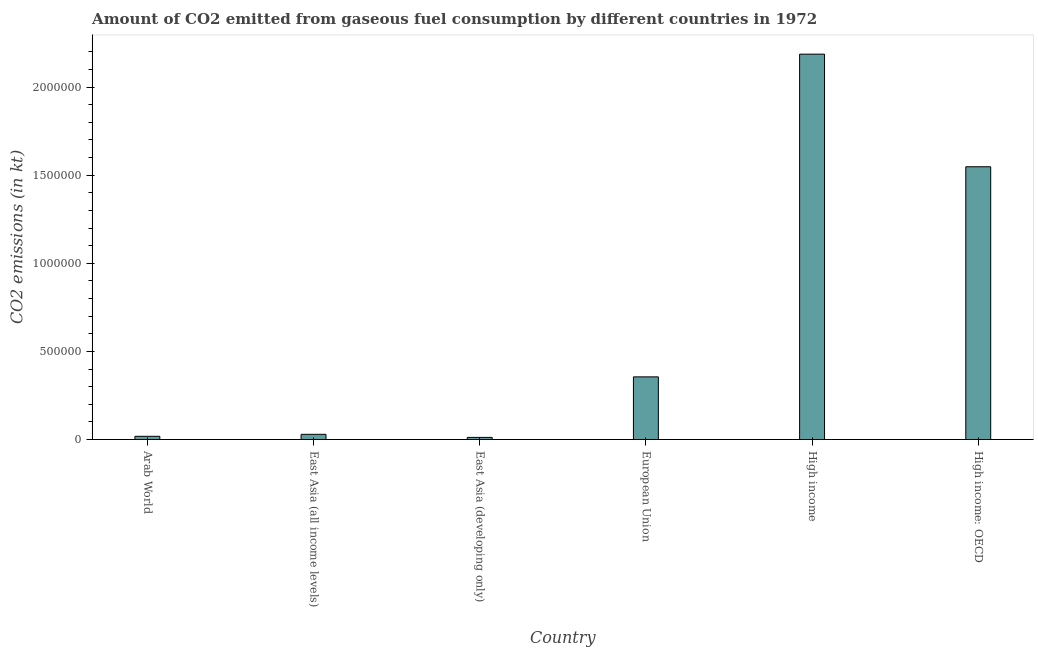Does the graph contain grids?
Your answer should be compact. No. What is the title of the graph?
Offer a terse response. Amount of CO2 emitted from gaseous fuel consumption by different countries in 1972. What is the label or title of the X-axis?
Your answer should be compact. Country. What is the label or title of the Y-axis?
Provide a short and direct response. CO2 emissions (in kt). What is the co2 emissions from gaseous fuel consumption in Arab World?
Provide a succinct answer. 1.83e+04. Across all countries, what is the maximum co2 emissions from gaseous fuel consumption?
Make the answer very short. 2.19e+06. Across all countries, what is the minimum co2 emissions from gaseous fuel consumption?
Keep it short and to the point. 1.21e+04. In which country was the co2 emissions from gaseous fuel consumption minimum?
Provide a short and direct response. East Asia (developing only). What is the sum of the co2 emissions from gaseous fuel consumption?
Give a very brief answer. 4.15e+06. What is the difference between the co2 emissions from gaseous fuel consumption in Arab World and High income: OECD?
Ensure brevity in your answer.  -1.53e+06. What is the average co2 emissions from gaseous fuel consumption per country?
Provide a succinct answer. 6.92e+05. What is the median co2 emissions from gaseous fuel consumption?
Your answer should be compact. 1.93e+05. In how many countries, is the co2 emissions from gaseous fuel consumption greater than 1900000 kt?
Offer a very short reply. 1. What is the ratio of the co2 emissions from gaseous fuel consumption in East Asia (all income levels) to that in High income?
Provide a succinct answer. 0.01. Is the co2 emissions from gaseous fuel consumption in Arab World less than that in High income?
Your answer should be very brief. Yes. Is the difference between the co2 emissions from gaseous fuel consumption in East Asia (all income levels) and European Union greater than the difference between any two countries?
Your response must be concise. No. What is the difference between the highest and the second highest co2 emissions from gaseous fuel consumption?
Provide a succinct answer. 6.39e+05. What is the difference between the highest and the lowest co2 emissions from gaseous fuel consumption?
Ensure brevity in your answer.  2.17e+06. How many countries are there in the graph?
Your response must be concise. 6. Are the values on the major ticks of Y-axis written in scientific E-notation?
Provide a succinct answer. No. What is the CO2 emissions (in kt) of Arab World?
Provide a succinct answer. 1.83e+04. What is the CO2 emissions (in kt) in East Asia (all income levels)?
Keep it short and to the point. 2.95e+04. What is the CO2 emissions (in kt) of East Asia (developing only)?
Offer a very short reply. 1.21e+04. What is the CO2 emissions (in kt) of European Union?
Your answer should be compact. 3.56e+05. What is the CO2 emissions (in kt) in High income?
Provide a succinct answer. 2.19e+06. What is the CO2 emissions (in kt) in High income: OECD?
Ensure brevity in your answer.  1.55e+06. What is the difference between the CO2 emissions (in kt) in Arab World and East Asia (all income levels)?
Keep it short and to the point. -1.13e+04. What is the difference between the CO2 emissions (in kt) in Arab World and East Asia (developing only)?
Keep it short and to the point. 6200.94. What is the difference between the CO2 emissions (in kt) in Arab World and European Union?
Make the answer very short. -3.37e+05. What is the difference between the CO2 emissions (in kt) in Arab World and High income?
Your answer should be compact. -2.17e+06. What is the difference between the CO2 emissions (in kt) in Arab World and High income: OECD?
Your response must be concise. -1.53e+06. What is the difference between the CO2 emissions (in kt) in East Asia (all income levels) and East Asia (developing only)?
Give a very brief answer. 1.75e+04. What is the difference between the CO2 emissions (in kt) in East Asia (all income levels) and European Union?
Your answer should be compact. -3.26e+05. What is the difference between the CO2 emissions (in kt) in East Asia (all income levels) and High income?
Your answer should be compact. -2.16e+06. What is the difference between the CO2 emissions (in kt) in East Asia (all income levels) and High income: OECD?
Give a very brief answer. -1.52e+06. What is the difference between the CO2 emissions (in kt) in East Asia (developing only) and European Union?
Keep it short and to the point. -3.43e+05. What is the difference between the CO2 emissions (in kt) in East Asia (developing only) and High income?
Your response must be concise. -2.17e+06. What is the difference between the CO2 emissions (in kt) in East Asia (developing only) and High income: OECD?
Offer a very short reply. -1.54e+06. What is the difference between the CO2 emissions (in kt) in European Union and High income?
Make the answer very short. -1.83e+06. What is the difference between the CO2 emissions (in kt) in European Union and High income: OECD?
Offer a terse response. -1.19e+06. What is the difference between the CO2 emissions (in kt) in High income and High income: OECD?
Your answer should be very brief. 6.39e+05. What is the ratio of the CO2 emissions (in kt) in Arab World to that in East Asia (all income levels)?
Your response must be concise. 0.62. What is the ratio of the CO2 emissions (in kt) in Arab World to that in East Asia (developing only)?
Provide a short and direct response. 1.51. What is the ratio of the CO2 emissions (in kt) in Arab World to that in European Union?
Provide a short and direct response. 0.05. What is the ratio of the CO2 emissions (in kt) in Arab World to that in High income?
Offer a terse response. 0.01. What is the ratio of the CO2 emissions (in kt) in Arab World to that in High income: OECD?
Your answer should be very brief. 0.01. What is the ratio of the CO2 emissions (in kt) in East Asia (all income levels) to that in East Asia (developing only)?
Your answer should be compact. 2.45. What is the ratio of the CO2 emissions (in kt) in East Asia (all income levels) to that in European Union?
Your response must be concise. 0.08. What is the ratio of the CO2 emissions (in kt) in East Asia (all income levels) to that in High income?
Ensure brevity in your answer.  0.01. What is the ratio of the CO2 emissions (in kt) in East Asia (all income levels) to that in High income: OECD?
Your answer should be very brief. 0.02. What is the ratio of the CO2 emissions (in kt) in East Asia (developing only) to that in European Union?
Ensure brevity in your answer.  0.03. What is the ratio of the CO2 emissions (in kt) in East Asia (developing only) to that in High income?
Offer a terse response. 0.01. What is the ratio of the CO2 emissions (in kt) in East Asia (developing only) to that in High income: OECD?
Your answer should be compact. 0.01. What is the ratio of the CO2 emissions (in kt) in European Union to that in High income?
Offer a terse response. 0.16. What is the ratio of the CO2 emissions (in kt) in European Union to that in High income: OECD?
Offer a very short reply. 0.23. What is the ratio of the CO2 emissions (in kt) in High income to that in High income: OECD?
Offer a terse response. 1.41. 